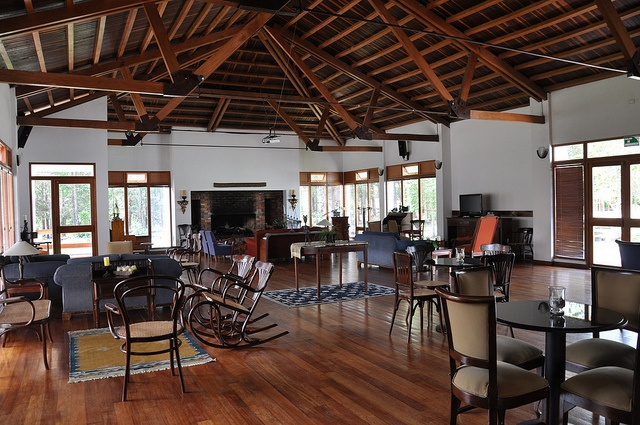Describe the objects in this image and their specific colors. I can see chair in black and gray tones, chair in black, gray, maroon, and darkgray tones, dining table in black, gray, darkgray, and white tones, chair in black, tan, maroon, and gray tones, and chair in black, maroon, and gray tones in this image. 